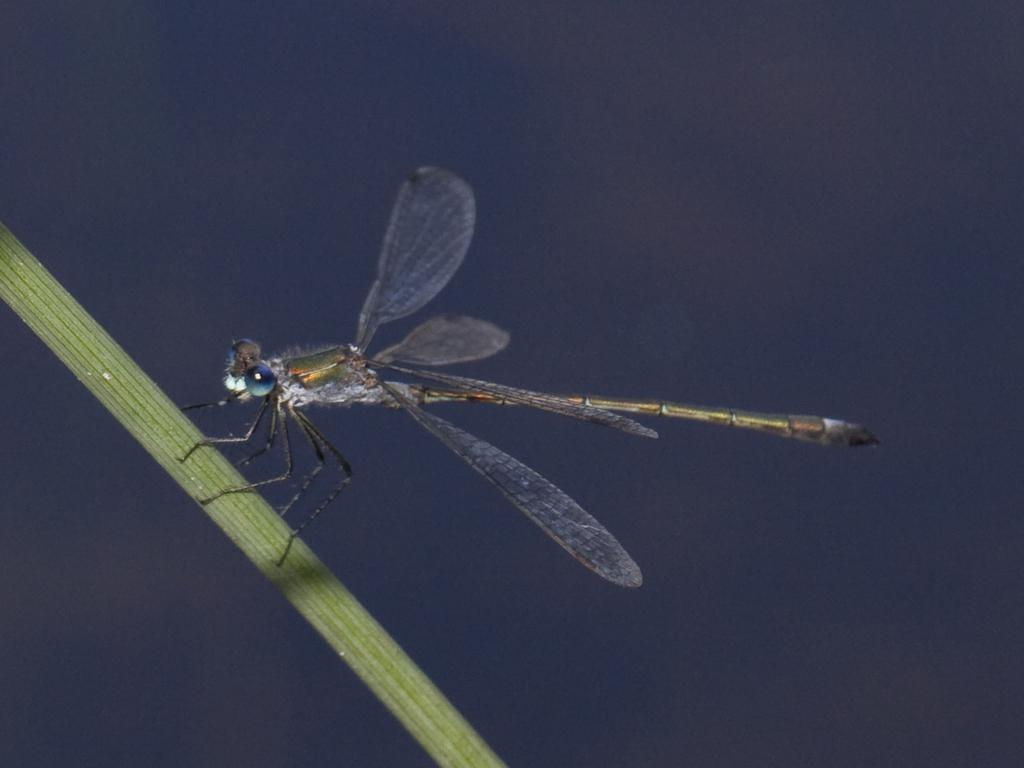What is present on the stem in the image? There is a fly on the stem in the image. Can you describe the location of the fly in the image? The fly is on a stem in the image. What type of drain is visible in the image? There is no drain present in the image; it only features a fly on a stem. 